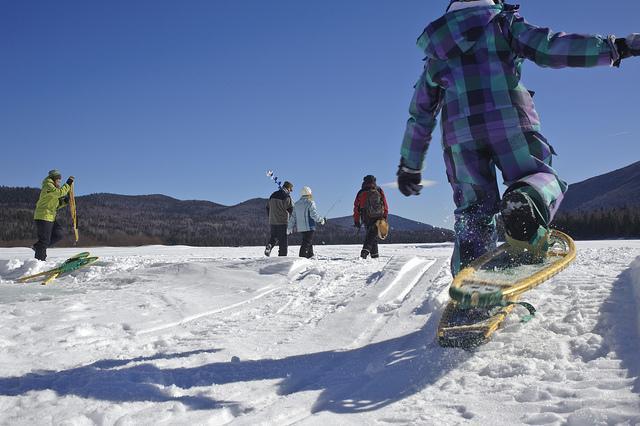How many people are visible?
Give a very brief answer. 2. 